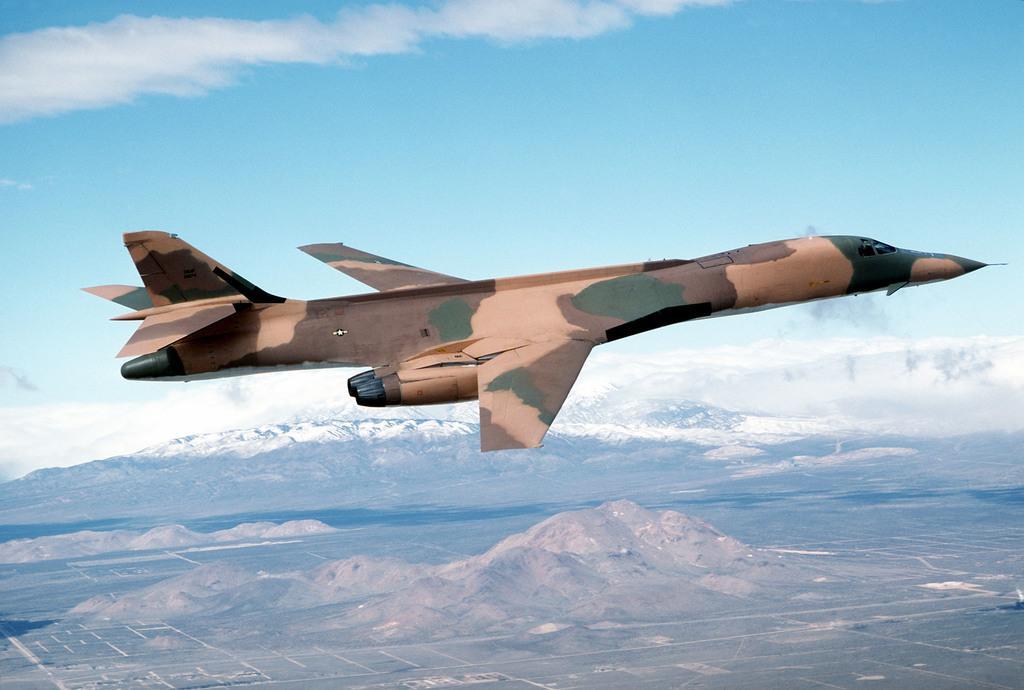Can you describe this image briefly? In this image we can see an airplane flying, there are some mountains and in the background, we can see the sky with clouds. 